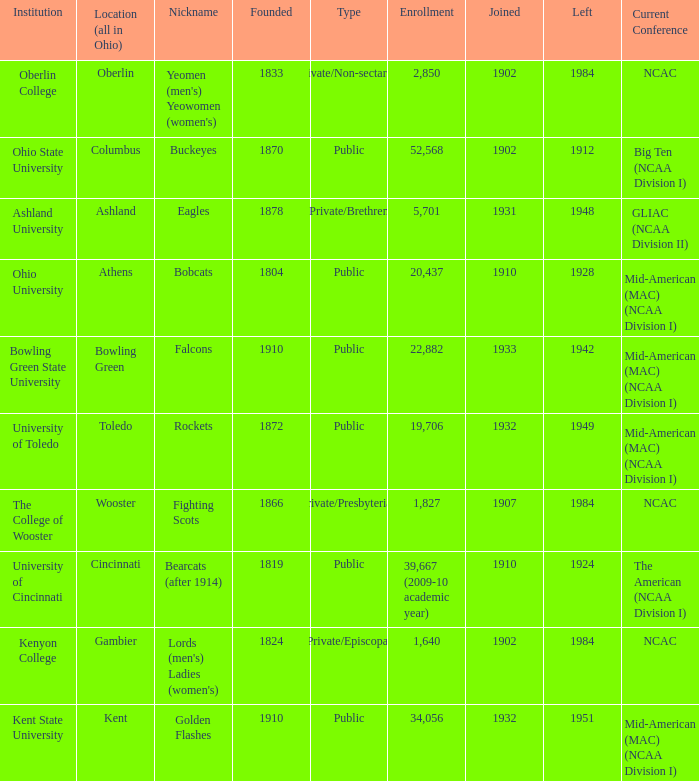What is the enrollment for Ashland University? 5701.0. 